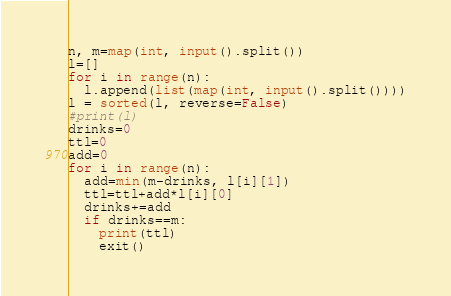<code> <loc_0><loc_0><loc_500><loc_500><_Python_>n, m=map(int, input().split())
l=[]
for i in range(n):
  l.append(list(map(int, input().split())))
l = sorted(l, reverse=False)  
#print(l)
drinks=0
ttl=0
add=0
for i in range(n):
  add=min(m-drinks, l[i][1])
  ttl=ttl+add*l[i][0]
  drinks+=add
  if drinks==m:
    print(ttl)
    exit()
</code> 